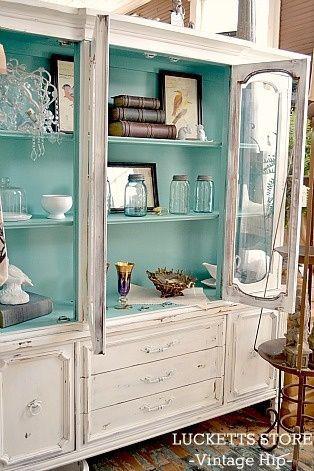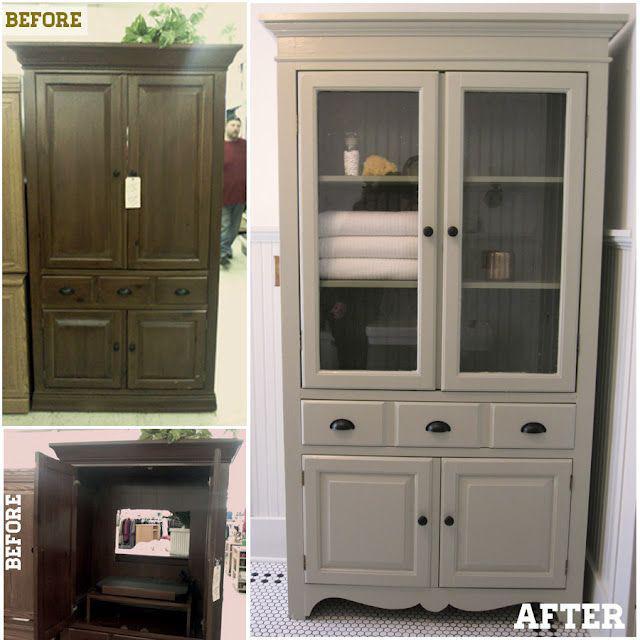The first image is the image on the left, the second image is the image on the right. Examine the images to the left and right. Is the description "The inside of one of the cabinets is an aqua color." accurate? Answer yes or no. Yes. The first image is the image on the left, the second image is the image on the right. Given the left and right images, does the statement "One cabinet has an open space with scrolled edges under the glass-front cabinets." hold true? Answer yes or no. No. 